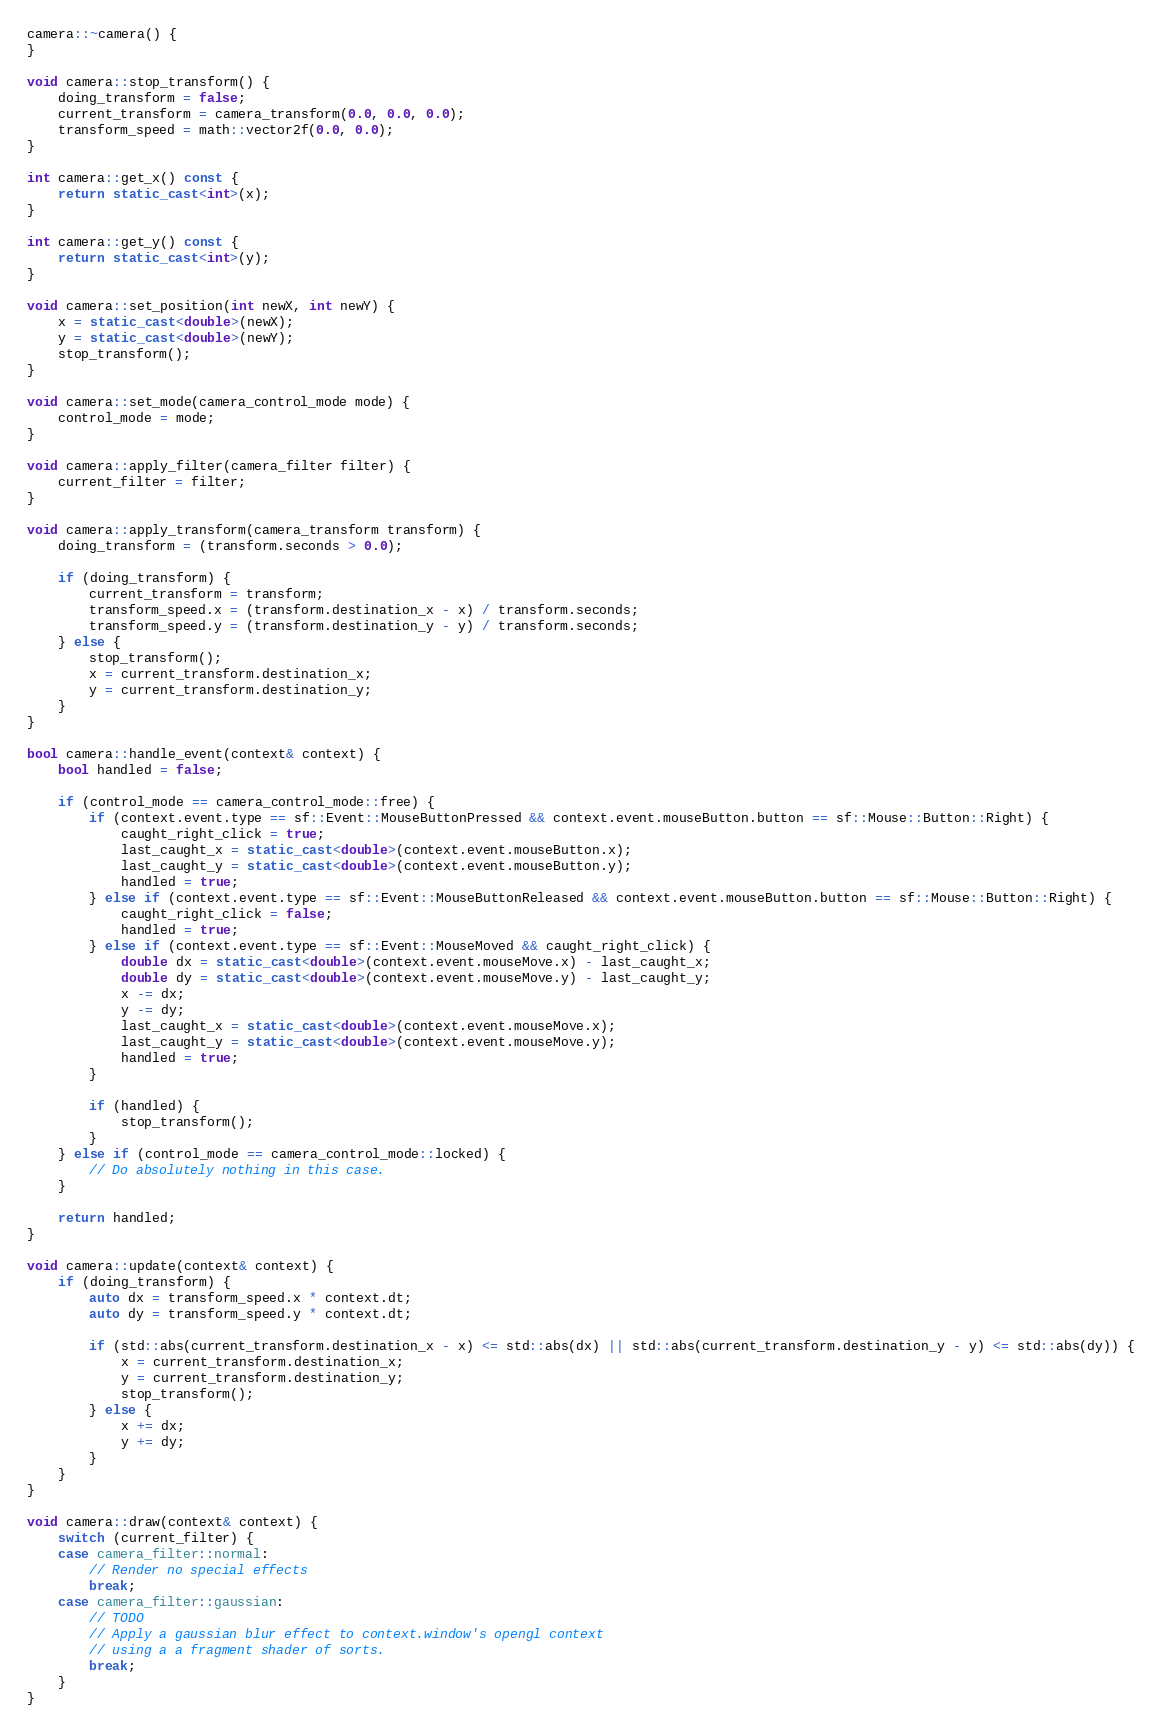Convert code to text. <code><loc_0><loc_0><loc_500><loc_500><_C++_>
camera::~camera() {
}

void camera::stop_transform() {
	doing_transform = false;
	current_transform = camera_transform(0.0, 0.0, 0.0);
	transform_speed = math::vector2f(0.0, 0.0);
}

int camera::get_x() const {
	return static_cast<int>(x);
}

int camera::get_y() const {
	return static_cast<int>(y);
}

void camera::set_position(int newX, int newY) {
	x = static_cast<double>(newX);
	y = static_cast<double>(newY);
	stop_transform();
}

void camera::set_mode(camera_control_mode mode) {
	control_mode = mode;
}

void camera::apply_filter(camera_filter filter) {
	current_filter = filter;
}

void camera::apply_transform(camera_transform transform) {
	doing_transform = (transform.seconds > 0.0);

	if (doing_transform) {
		current_transform = transform;
		transform_speed.x = (transform.destination_x - x) / transform.seconds;
		transform_speed.y = (transform.destination_y - y) / transform.seconds;
	} else {
		stop_transform();
		x = current_transform.destination_x;
		y = current_transform.destination_y;
	}
}

bool camera::handle_event(context& context) {
	bool handled = false;
    
	if (control_mode == camera_control_mode::free) {
		if (context.event.type == sf::Event::MouseButtonPressed && context.event.mouseButton.button == sf::Mouse::Button::Right) {
			caught_right_click = true;
			last_caught_x = static_cast<double>(context.event.mouseButton.x);
			last_caught_y = static_cast<double>(context.event.mouseButton.y);
			handled = true;
		} else if (context.event.type == sf::Event::MouseButtonReleased && context.event.mouseButton.button == sf::Mouse::Button::Right) {
			caught_right_click = false;
			handled = true;
		} else if (context.event.type == sf::Event::MouseMoved && caught_right_click) {
			double dx = static_cast<double>(context.event.mouseMove.x) - last_caught_x;
			double dy = static_cast<double>(context.event.mouseMove.y) - last_caught_y;
			x -= dx;
			y -= dy;
			last_caught_x = static_cast<double>(context.event.mouseMove.x);
			last_caught_y = static_cast<double>(context.event.mouseMove.y);
			handled = true;
		}

		if (handled) {
			stop_transform();
		}
	} else if (control_mode == camera_control_mode::locked) {
		// Do absolutely nothing in this case.
	}
    
	return handled;
}

void camera::update(context& context) {
	if (doing_transform) {
		auto dx = transform_speed.x * context.dt;
		auto dy = transform_speed.y * context.dt;

		if (std::abs(current_transform.destination_x - x) <= std::abs(dx) || std::abs(current_transform.destination_y - y) <= std::abs(dy)) {
			x = current_transform.destination_x;
			y = current_transform.destination_y;
			stop_transform();
		} else {
			x += dx;
			y += dy;
		}
	}
}

void camera::draw(context& context) {
	switch (current_filter) {
	case camera_filter::normal:
		// Render no special effects
		break;
	case camera_filter::gaussian:
		// TODO
		// Apply a gaussian blur effect to context.window's opengl context
		// using a a fragment shader of sorts.
		break;
	}
}</code> 